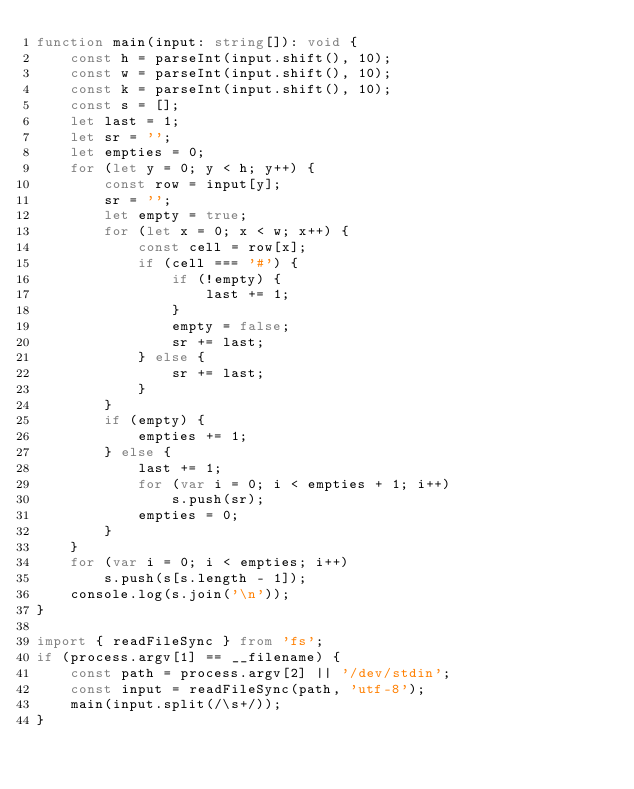<code> <loc_0><loc_0><loc_500><loc_500><_TypeScript_>function main(input: string[]): void {
    const h = parseInt(input.shift(), 10);
    const w = parseInt(input.shift(), 10);
    const k = parseInt(input.shift(), 10);
    const s = [];
    let last = 1;
    let sr = '';
    let empties = 0;
    for (let y = 0; y < h; y++) {
        const row = input[y];
        sr = '';
        let empty = true;
        for (let x = 0; x < w; x++) {
            const cell = row[x];
            if (cell === '#') {
                if (!empty) {
                    last += 1;
                }
                empty = false;
                sr += last;
            } else {
                sr += last;
            }
        }
        if (empty) {
            empties += 1;
        } else {
            last += 1;
            for (var i = 0; i < empties + 1; i++)
                s.push(sr);
            empties = 0;
        }
    }
    for (var i = 0; i < empties; i++)
        s.push(s[s.length - 1]);
    console.log(s.join('\n'));
}

import { readFileSync } from 'fs';
if (process.argv[1] == __filename) {
    const path = process.argv[2] || '/dev/stdin';
    const input = readFileSync(path, 'utf-8');
    main(input.split(/\s+/));
}</code> 